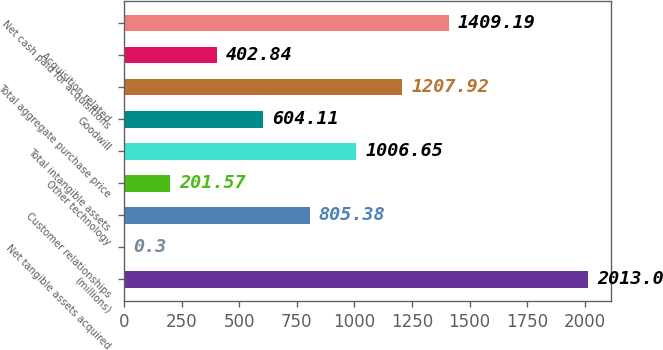Convert chart. <chart><loc_0><loc_0><loc_500><loc_500><bar_chart><fcel>(millions)<fcel>Net tangible assets acquired<fcel>Customer relationships<fcel>Other technology<fcel>Total intangible assets<fcel>Goodwill<fcel>Total aggregate purchase price<fcel>Acquisition related<fcel>Net cash paid for acquisitions<nl><fcel>2013<fcel>0.3<fcel>805.38<fcel>201.57<fcel>1006.65<fcel>604.11<fcel>1207.92<fcel>402.84<fcel>1409.19<nl></chart> 